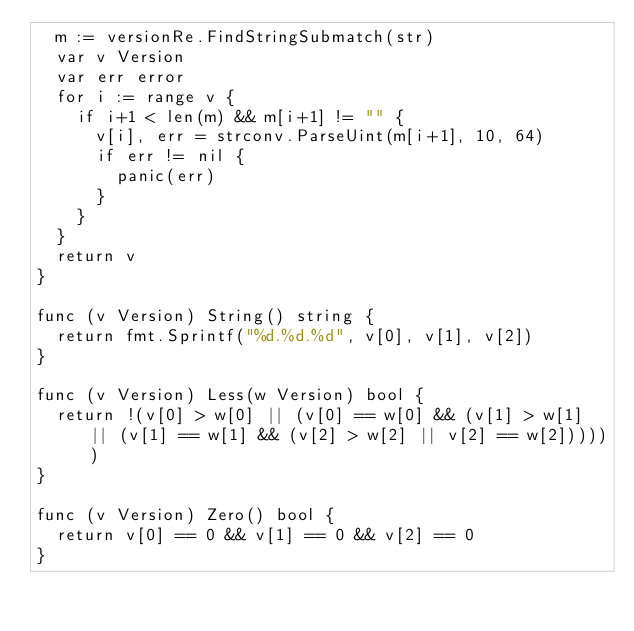<code> <loc_0><loc_0><loc_500><loc_500><_Go_>	m := versionRe.FindStringSubmatch(str)
	var v Version
	var err error
	for i := range v {
		if i+1 < len(m) && m[i+1] != "" {
			v[i], err = strconv.ParseUint(m[i+1], 10, 64)
			if err != nil {
				panic(err)
			}
		}
	}
	return v
}

func (v Version) String() string {
	return fmt.Sprintf("%d.%d.%d", v[0], v[1], v[2])
}

func (v Version) Less(w Version) bool {
	return !(v[0] > w[0] || (v[0] == w[0] && (v[1] > w[1] || (v[1] == w[1] && (v[2] > w[2] || v[2] == w[2])))))
}

func (v Version) Zero() bool {
	return v[0] == 0 && v[1] == 0 && v[2] == 0
}
</code> 